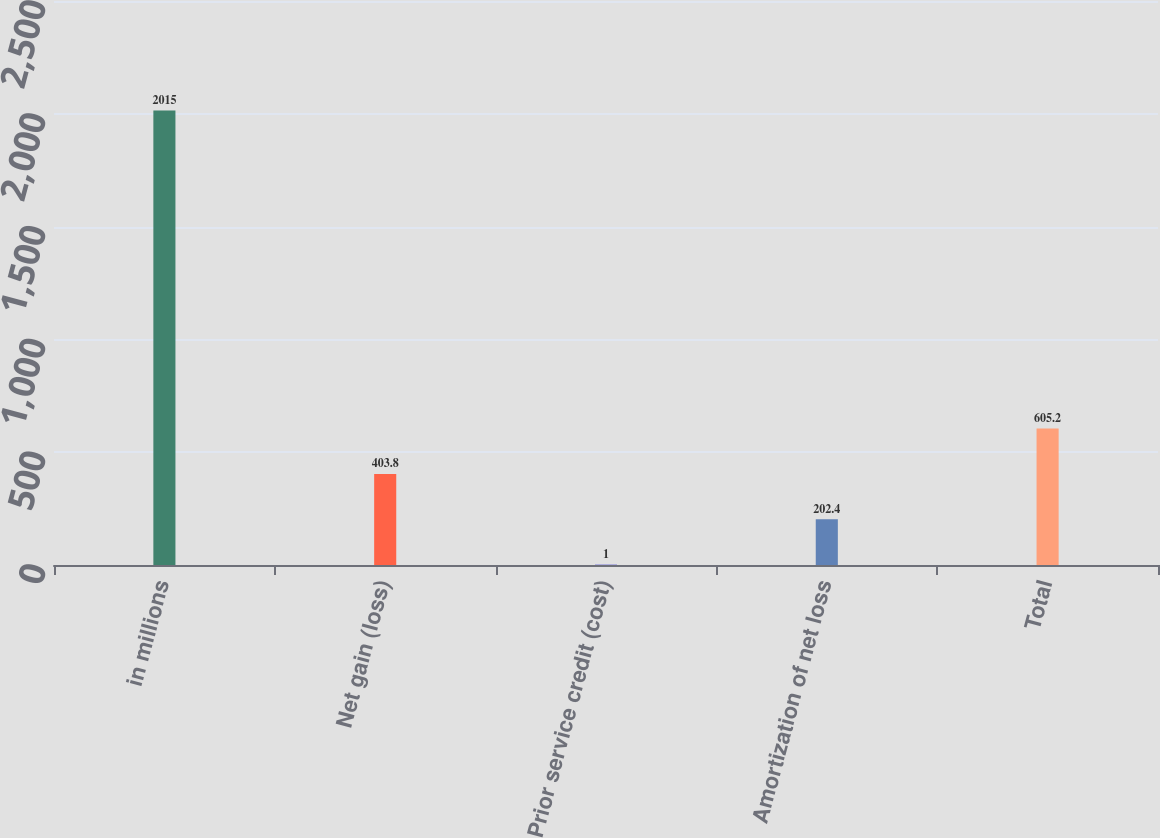<chart> <loc_0><loc_0><loc_500><loc_500><bar_chart><fcel>in millions<fcel>Net gain (loss)<fcel>Prior service credit (cost)<fcel>Amortization of net loss<fcel>Total<nl><fcel>2015<fcel>403.8<fcel>1<fcel>202.4<fcel>605.2<nl></chart> 